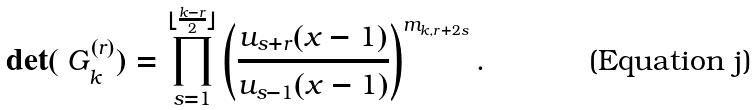<formula> <loc_0><loc_0><loc_500><loc_500>\det ( \ G _ { k } ^ { ( r ) } ) = \prod _ { s = 1 } ^ { \lfloor \frac { k - r } { 2 } \rfloor } \left ( \frac { u _ { s + r } ( x - 1 ) } { u _ { s - 1 } ( x - 1 ) } \right ) ^ { m _ { k , r + 2 s } } .</formula> 